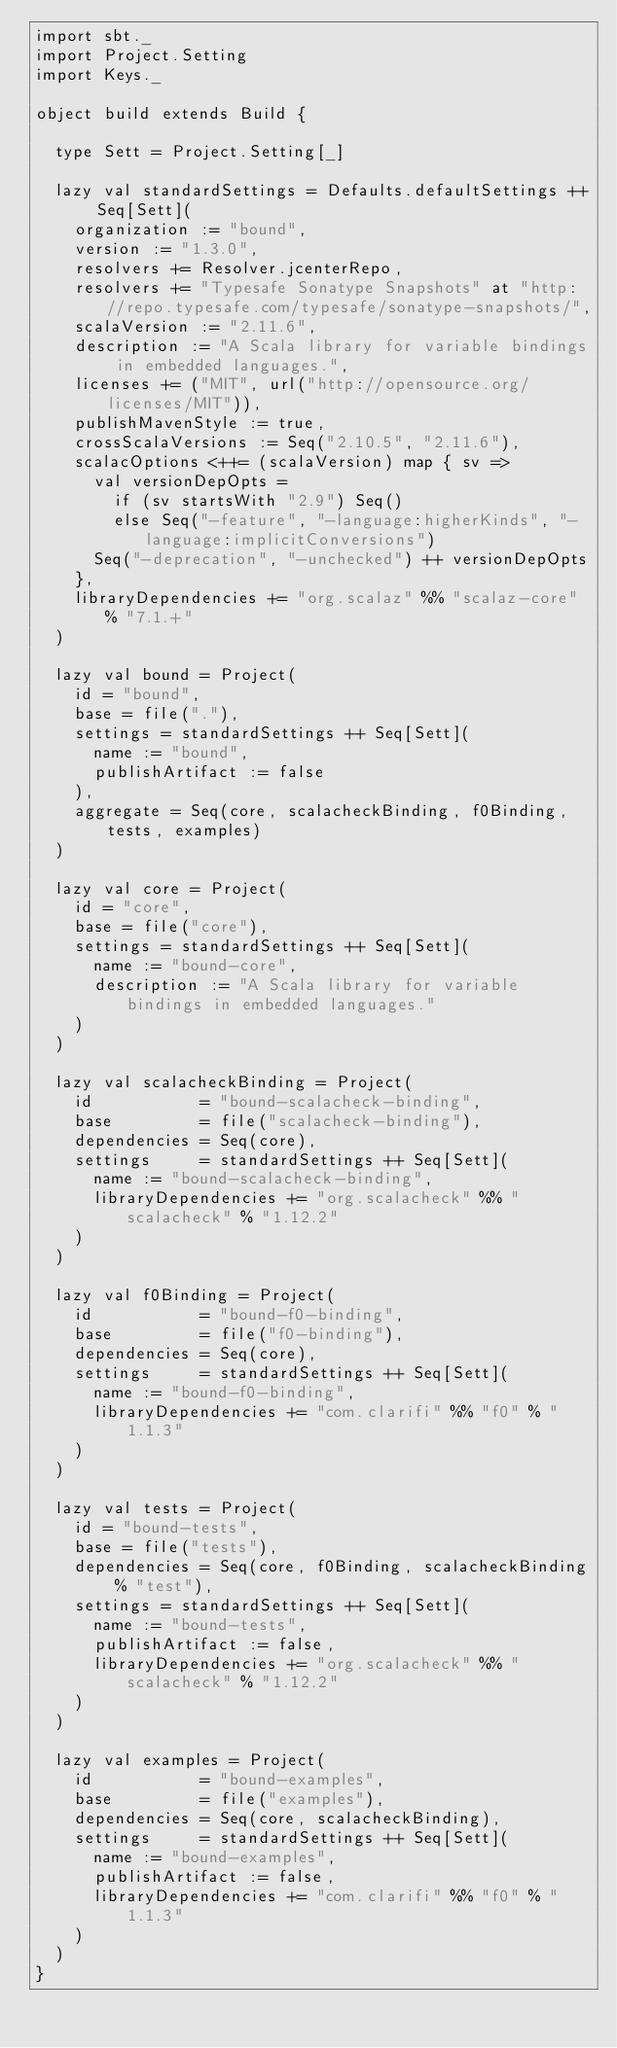Convert code to text. <code><loc_0><loc_0><loc_500><loc_500><_Scala_>import sbt._
import Project.Setting
import Keys._

object build extends Build {

  type Sett = Project.Setting[_]

  lazy val standardSettings = Defaults.defaultSettings ++ Seq[Sett](
    organization := "bound",
    version := "1.3.0",
    resolvers += Resolver.jcenterRepo,
    resolvers += "Typesafe Sonatype Snapshots" at "http://repo.typesafe.com/typesafe/sonatype-snapshots/",
    scalaVersion := "2.11.6",
    description := "A Scala library for variable bindings in embedded languages.",
    licenses += ("MIT", url("http://opensource.org/licenses/MIT")),
    publishMavenStyle := true,
    crossScalaVersions := Seq("2.10.5", "2.11.6"),
    scalacOptions <++= (scalaVersion) map { sv =>
      val versionDepOpts =
        if (sv startsWith "2.9") Seq()
        else Seq("-feature", "-language:higherKinds", "-language:implicitConversions")
      Seq("-deprecation", "-unchecked") ++ versionDepOpts
    },
    libraryDependencies += "org.scalaz" %% "scalaz-core" % "7.1.+"
  )

  lazy val bound = Project(
    id = "bound",
    base = file("."),
    settings = standardSettings ++ Seq[Sett](
      name := "bound",
      publishArtifact := false
    ),
    aggregate = Seq(core, scalacheckBinding, f0Binding, tests, examples)
  )

  lazy val core = Project(
    id = "core",
    base = file("core"),
    settings = standardSettings ++ Seq[Sett](
      name := "bound-core",
      description := "A Scala library for variable bindings in embedded languages."
    )
  )

  lazy val scalacheckBinding = Project(
    id           = "bound-scalacheck-binding",
    base         = file("scalacheck-binding"),
    dependencies = Seq(core),
    settings     = standardSettings ++ Seq[Sett](
      name := "bound-scalacheck-binding",
      libraryDependencies += "org.scalacheck" %% "scalacheck" % "1.12.2"
    )
  )

  lazy val f0Binding = Project(
    id           = "bound-f0-binding",
    base         = file("f0-binding"),
    dependencies = Seq(core),
    settings     = standardSettings ++ Seq[Sett](
      name := "bound-f0-binding",
      libraryDependencies += "com.clarifi" %% "f0" % "1.1.3"
    )
  )

  lazy val tests = Project(
    id = "bound-tests",
    base = file("tests"),
    dependencies = Seq(core, f0Binding, scalacheckBinding % "test"),
    settings = standardSettings ++ Seq[Sett](
      name := "bound-tests",
      publishArtifact := false,
      libraryDependencies += "org.scalacheck" %% "scalacheck" % "1.12.2"
    )
  )

  lazy val examples = Project(
    id           = "bound-examples",
    base         = file("examples"),
    dependencies = Seq(core, scalacheckBinding),
    settings     = standardSettings ++ Seq[Sett](
      name := "bound-examples",
      publishArtifact := false,
      libraryDependencies += "com.clarifi" %% "f0" % "1.1.3"
    )
  )
}
</code> 